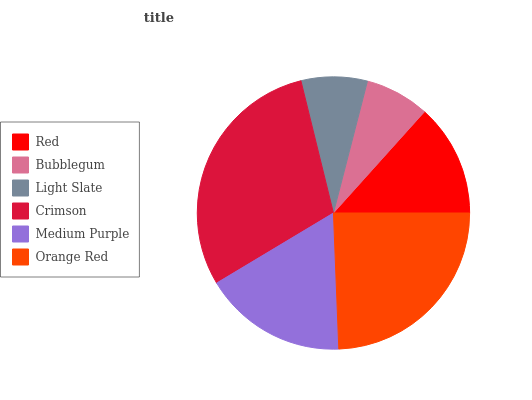Is Bubblegum the minimum?
Answer yes or no. Yes. Is Crimson the maximum?
Answer yes or no. Yes. Is Light Slate the minimum?
Answer yes or no. No. Is Light Slate the maximum?
Answer yes or no. No. Is Light Slate greater than Bubblegum?
Answer yes or no. Yes. Is Bubblegum less than Light Slate?
Answer yes or no. Yes. Is Bubblegum greater than Light Slate?
Answer yes or no. No. Is Light Slate less than Bubblegum?
Answer yes or no. No. Is Medium Purple the high median?
Answer yes or no. Yes. Is Red the low median?
Answer yes or no. Yes. Is Bubblegum the high median?
Answer yes or no. No. Is Bubblegum the low median?
Answer yes or no. No. 